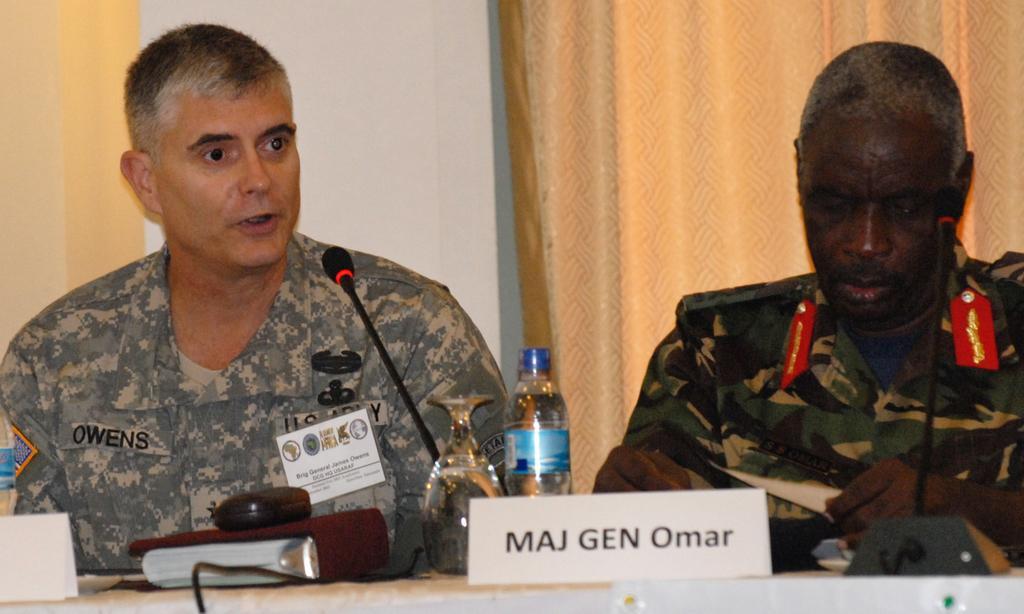How would you summarize this image in a sentence or two? In this image, there are two people sitting and in the front, we can see a bottle, glass, mic and name boards which are on the table. 